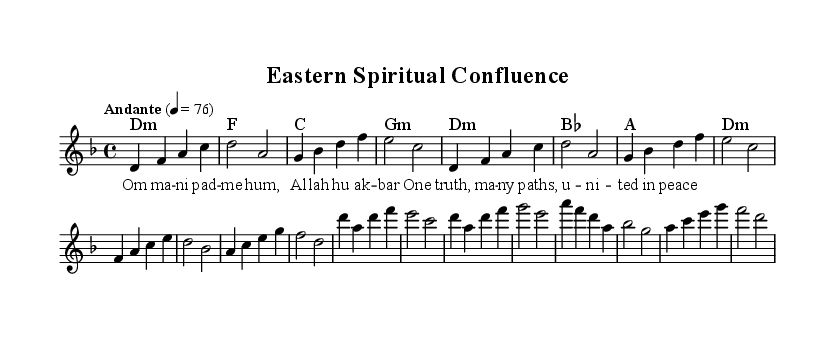What is the key signature of this music? The key signature is D minor, which has one flat (B flat). This can be determined from the beginning of the staff where the key signature is placed.
Answer: D minor What is the time signature of the piece? The time signature is 4/4, indicated at the beginning of the music. This means there are four beats in each measure, and the quarter note gets one beat.
Answer: 4/4 What is the tempo marking? The tempo marking is "Andante," which indicates a moderately slow tempo. This is stated at the beginning of the piece along with the metronome marking of 76 beats per minute.
Answer: Andante How many measures are there in the melody? The melody consists of 12 measures, as can be counted from the bars in the melody section indicated in the music.
Answer: 12 What are the repeated lines in the lyrics? The repeated lines are found in the chorus section, specifically "One truth, many paths, united in peace." This can be confirmed by identifying the lyrics written under the melody lines in the chorus section.
Answer: One truth, many paths, united in peace Which religious phrases are included in the lyrics? The lyrics include "Om ma -- ni pad -- me hum" and "Al -- lah hu ak -- bar", which are specific to Buddhist and Islamic traditions, respectively. This distinction can be made by analyzing the words in the verse section of the lyrics written under the melody.
Answer: Om ma -- ni pad -- me hum, Al -- lah hu ak -- bar 